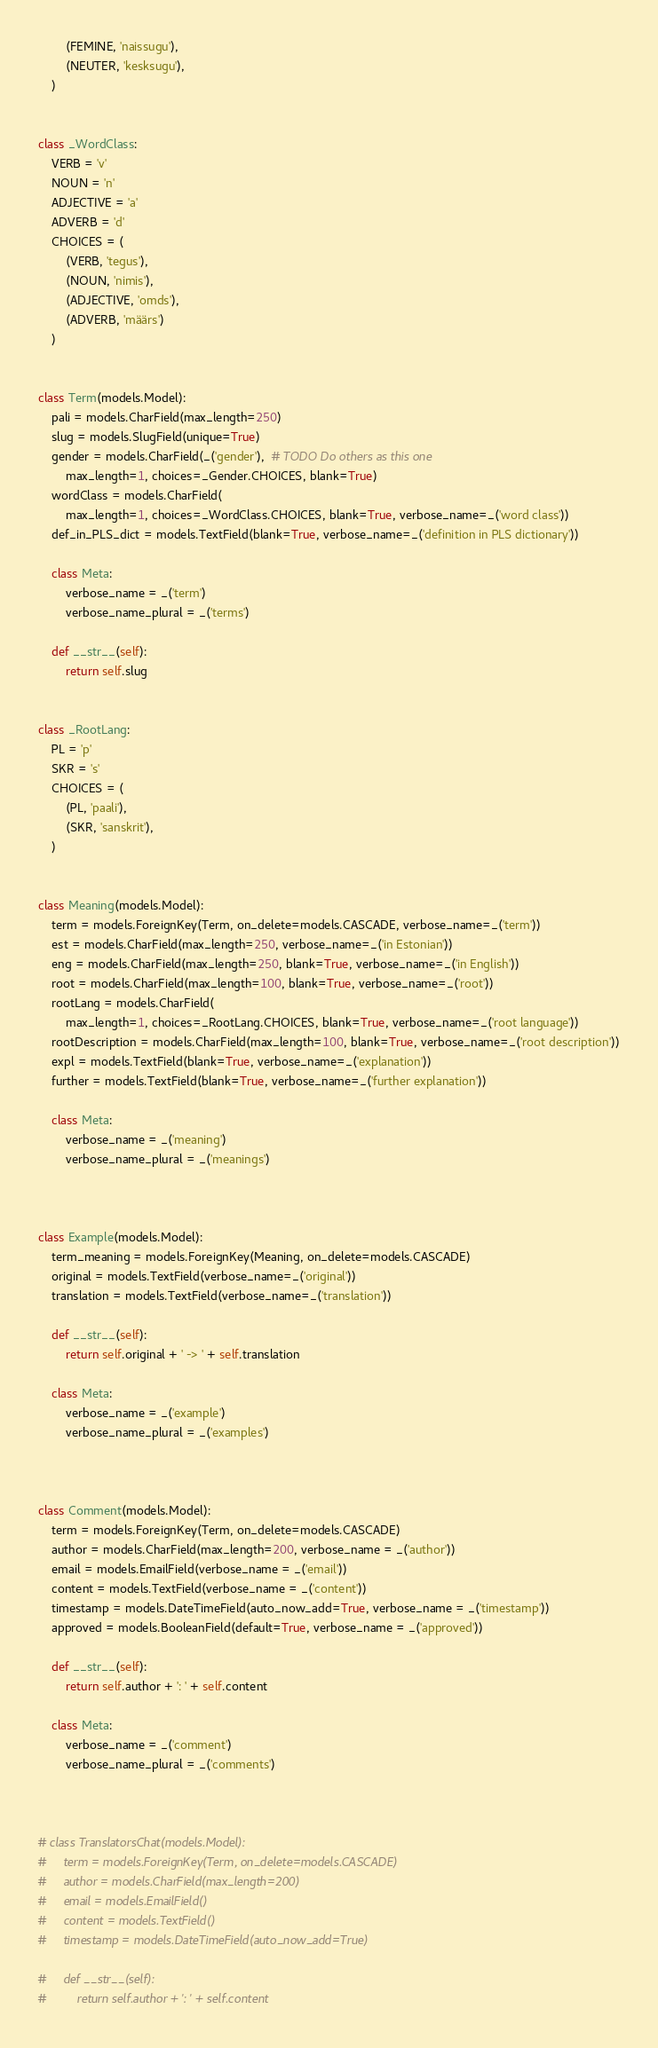<code> <loc_0><loc_0><loc_500><loc_500><_Python_>        (FEMINE, 'naissugu'),
        (NEUTER, 'kesksugu'),
    )


class _WordClass:
    VERB = 'v'
    NOUN = 'n'
    ADJECTIVE = 'a'
    ADVERB = 'd'
    CHOICES = (
        (VERB, 'tegus'),
        (NOUN, 'nimis'),
        (ADJECTIVE, 'omds'),
        (ADVERB, 'määrs')
    )


class Term(models.Model):
    pali = models.CharField(max_length=250)
    slug = models.SlugField(unique=True)
    gender = models.CharField(_('gender'),  # TODO Do others as this one
        max_length=1, choices=_Gender.CHOICES, blank=True)
    wordClass = models.CharField(
        max_length=1, choices=_WordClass.CHOICES, blank=True, verbose_name=_('word class'))
    def_in_PLS_dict = models.TextField(blank=True, verbose_name=_('definition in PLS dictionary'))

    class Meta:
        verbose_name = _('term')
        verbose_name_plural = _('terms')

    def __str__(self):
        return self.slug


class _RootLang:
    PL = 'p'
    SKR = 's'
    CHOICES = (
        (PL, 'paali'),
        (SKR, 'sanskrit'),
    )


class Meaning(models.Model):
    term = models.ForeignKey(Term, on_delete=models.CASCADE, verbose_name=_('term'))
    est = models.CharField(max_length=250, verbose_name=_('in Estonian'))
    eng = models.CharField(max_length=250, blank=True, verbose_name=_('in English'))
    root = models.CharField(max_length=100, blank=True, verbose_name=_('root'))
    rootLang = models.CharField(
        max_length=1, choices=_RootLang.CHOICES, blank=True, verbose_name=_('root language'))
    rootDescription = models.CharField(max_length=100, blank=True, verbose_name=_('root description'))
    expl = models.TextField(blank=True, verbose_name=_('explanation'))
    further = models.TextField(blank=True, verbose_name=_('further explanation'))

    class Meta:
        verbose_name = _('meaning')
        verbose_name_plural = _('meanings')



class Example(models.Model):
    term_meaning = models.ForeignKey(Meaning, on_delete=models.CASCADE)
    original = models.TextField(verbose_name=_('original'))
    translation = models.TextField(verbose_name=_('translation'))

    def __str__(self):
        return self.original + ' -> ' + self.translation
    
    class Meta:
        verbose_name = _('example')
        verbose_name_plural = _('examples')



class Comment(models.Model):
    term = models.ForeignKey(Term, on_delete=models.CASCADE)
    author = models.CharField(max_length=200, verbose_name = _('author'))
    email = models.EmailField(verbose_name = _('email'))
    content = models.TextField(verbose_name = _('content'))
    timestamp = models.DateTimeField(auto_now_add=True, verbose_name = _('timestamp'))
    approved = models.BooleanField(default=True, verbose_name = _('approved'))

    def __str__(self):
        return self.author + ': ' + self.content

    class Meta:
        verbose_name = _('comment')
        verbose_name_plural = _('comments')



# class TranslatorsChat(models.Model):
#     term = models.ForeignKey(Term, on_delete=models.CASCADE)
#     author = models.CharField(max_length=200)
#     email = models.EmailField()
#     content = models.TextField()
#     timestamp = models.DateTimeField(auto_now_add=True)

#     def __str__(self):
#         return self.author + ': ' + self.content
</code> 